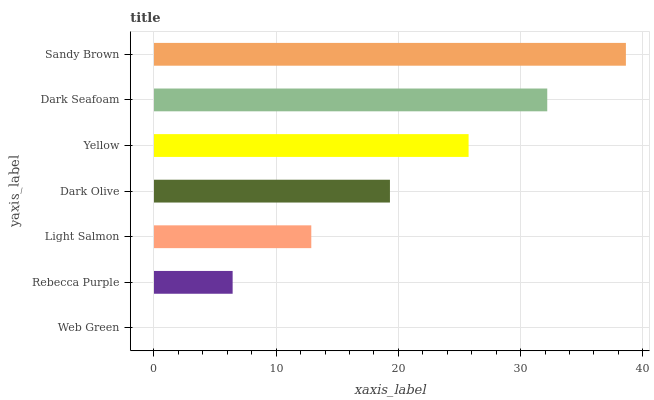Is Web Green the minimum?
Answer yes or no. Yes. Is Sandy Brown the maximum?
Answer yes or no. Yes. Is Rebecca Purple the minimum?
Answer yes or no. No. Is Rebecca Purple the maximum?
Answer yes or no. No. Is Rebecca Purple greater than Web Green?
Answer yes or no. Yes. Is Web Green less than Rebecca Purple?
Answer yes or no. Yes. Is Web Green greater than Rebecca Purple?
Answer yes or no. No. Is Rebecca Purple less than Web Green?
Answer yes or no. No. Is Dark Olive the high median?
Answer yes or no. Yes. Is Dark Olive the low median?
Answer yes or no. Yes. Is Dark Seafoam the high median?
Answer yes or no. No. Is Sandy Brown the low median?
Answer yes or no. No. 